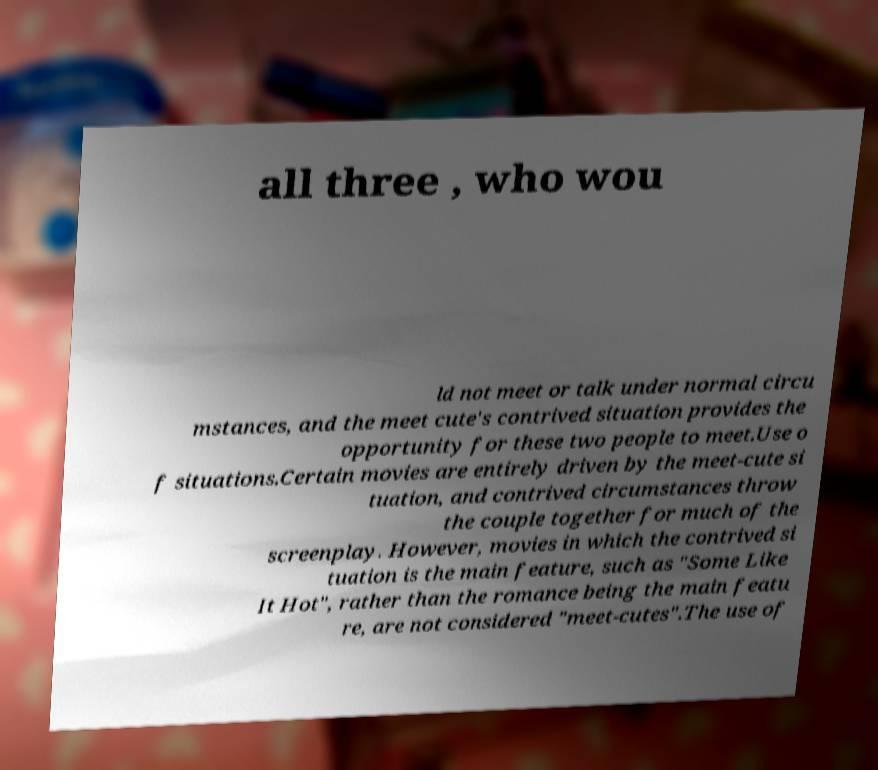Please identify and transcribe the text found in this image. all three , who wou ld not meet or talk under normal circu mstances, and the meet cute's contrived situation provides the opportunity for these two people to meet.Use o f situations.Certain movies are entirely driven by the meet-cute si tuation, and contrived circumstances throw the couple together for much of the screenplay. However, movies in which the contrived si tuation is the main feature, such as "Some Like It Hot", rather than the romance being the main featu re, are not considered "meet-cutes".The use of 